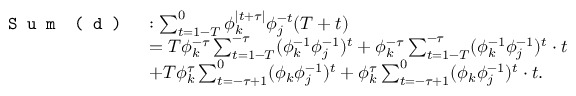<formula> <loc_0><loc_0><loc_500><loc_500>\begin{array} { r l } { S u m ( d ) } & { \colon \sum _ { t = 1 - T } ^ { 0 } \phi _ { k } ^ { | t + \tau | } \phi _ { j } ^ { - t } ( T + t ) } \\ & { = T \phi _ { k } ^ { - \tau } \sum _ { t = 1 - T } ^ { - \tau } ( \phi _ { k } ^ { - 1 } \phi _ { j } ^ { - 1 } ) ^ { t } + \phi _ { k } ^ { - \tau } \sum _ { t = 1 - T } ^ { - \tau } ( \phi _ { k } ^ { - 1 } \phi _ { j } ^ { - 1 } ) ^ { t } \cdot t } \\ & { + T \phi _ { k } ^ { \tau } \sum _ { t = - \tau + 1 } ^ { 0 } ( \phi _ { k } \phi _ { j } ^ { - 1 } ) ^ { t } + \phi _ { k } ^ { \tau } \sum _ { t = - \tau + 1 } ^ { 0 } ( \phi _ { k } \phi _ { j } ^ { - 1 } ) ^ { t } \cdot t . } \end{array}</formula> 